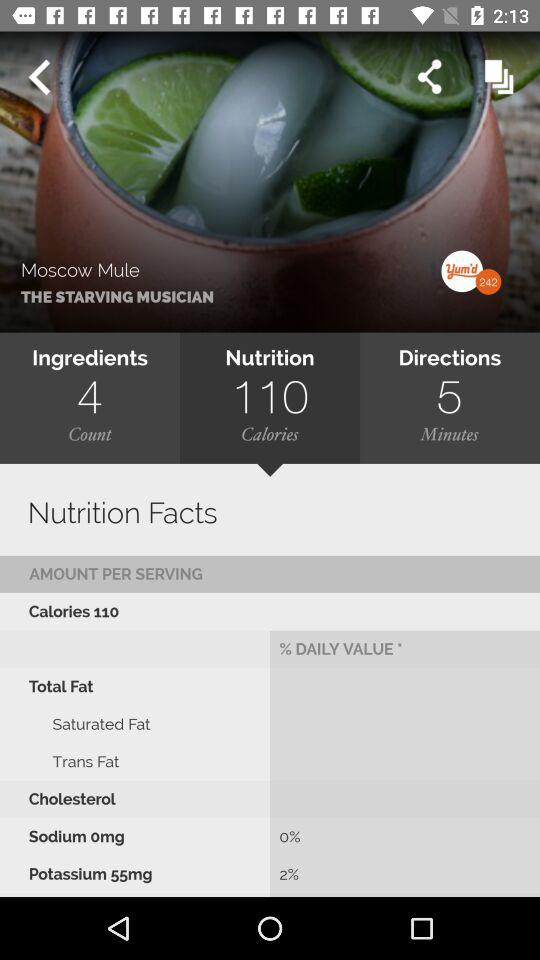How many calories of nutrition are there in "Moscow Mule"? There are 110 calories of nutrition in "Moscow Mule". 